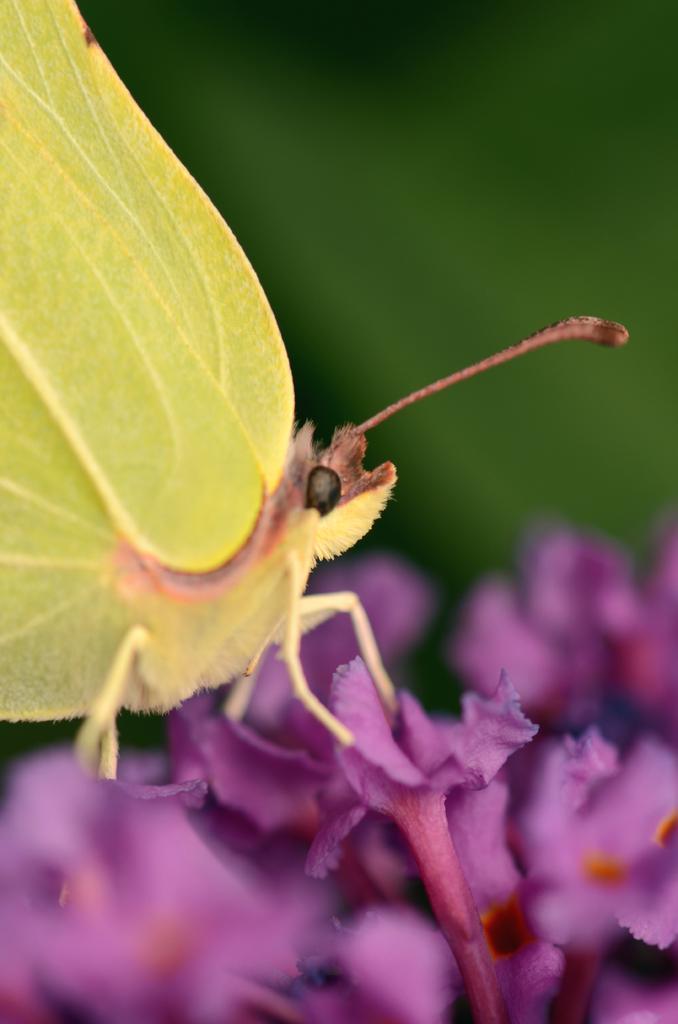In one or two sentences, can you explain what this image depicts? This image is taken outdoors. In this image the background is a little blurred. At the bottom of the image there are a few flowers which are purple in color. On the left side of the image there is a butterfly on the flower which is yellow in color. 